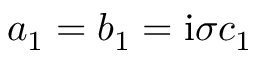<formula> <loc_0><loc_0><loc_500><loc_500>a _ { 1 } = b _ { 1 } = i \sigma c _ { 1 }</formula> 